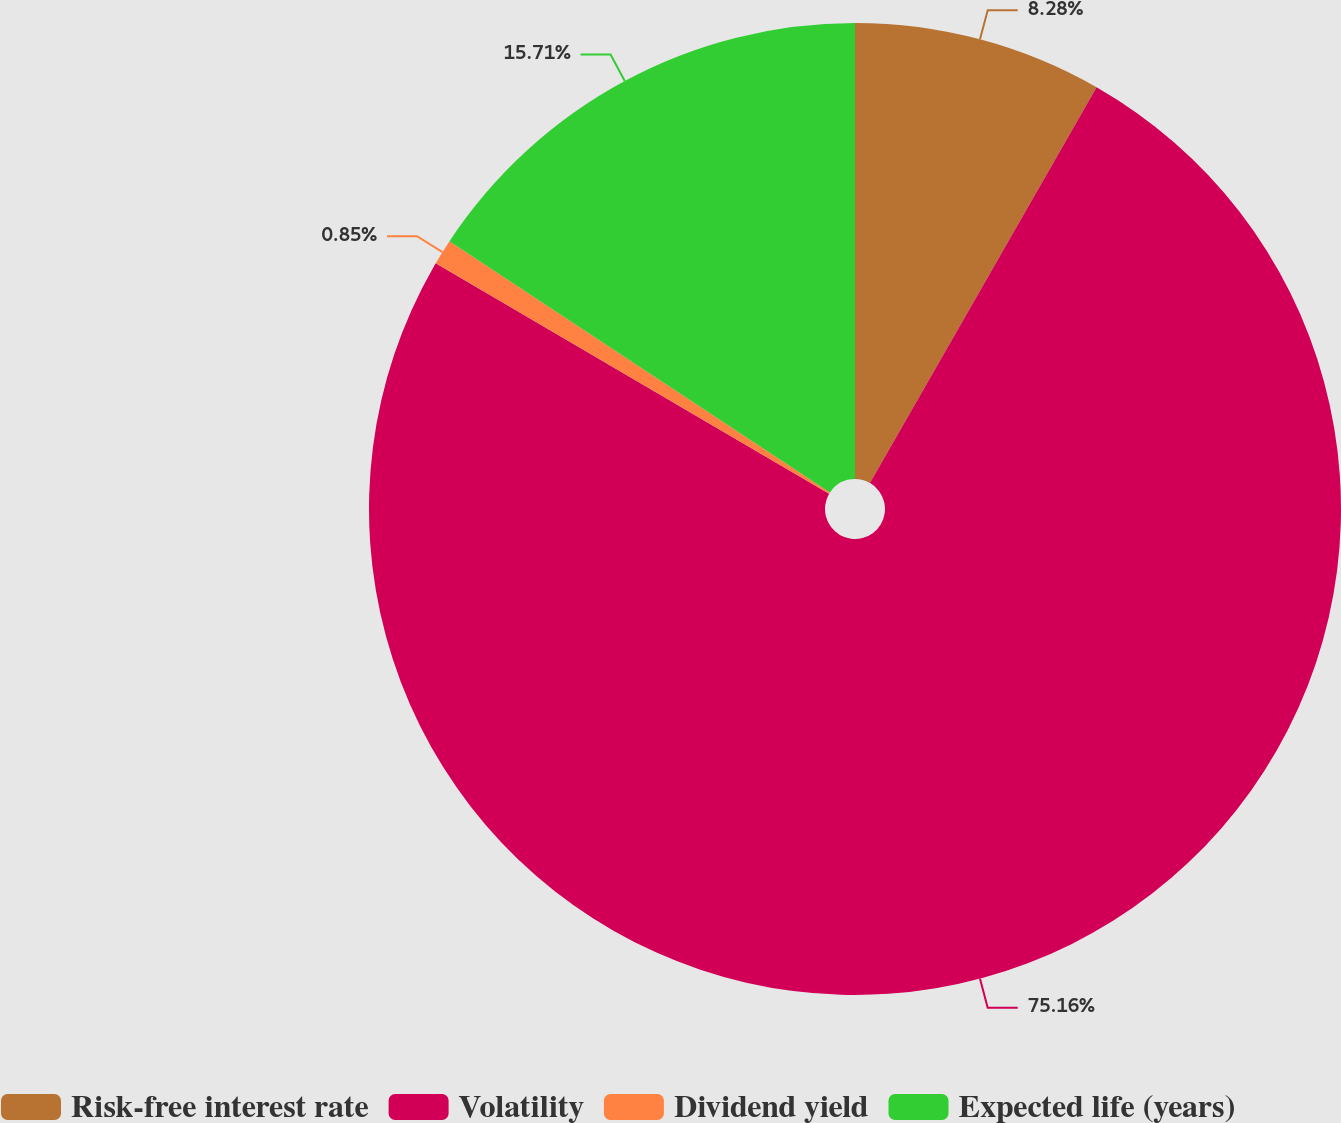Convert chart. <chart><loc_0><loc_0><loc_500><loc_500><pie_chart><fcel>Risk-free interest rate<fcel>Volatility<fcel>Dividend yield<fcel>Expected life (years)<nl><fcel>8.28%<fcel>75.16%<fcel>0.85%<fcel>15.71%<nl></chart> 